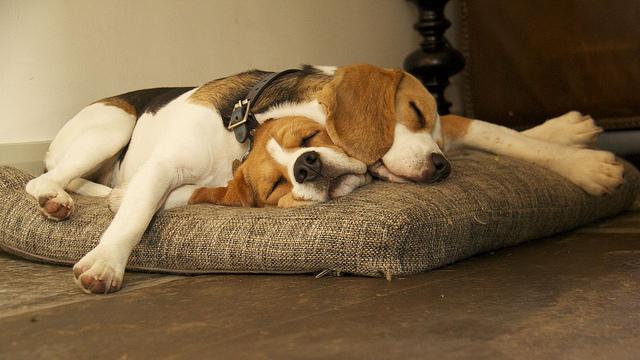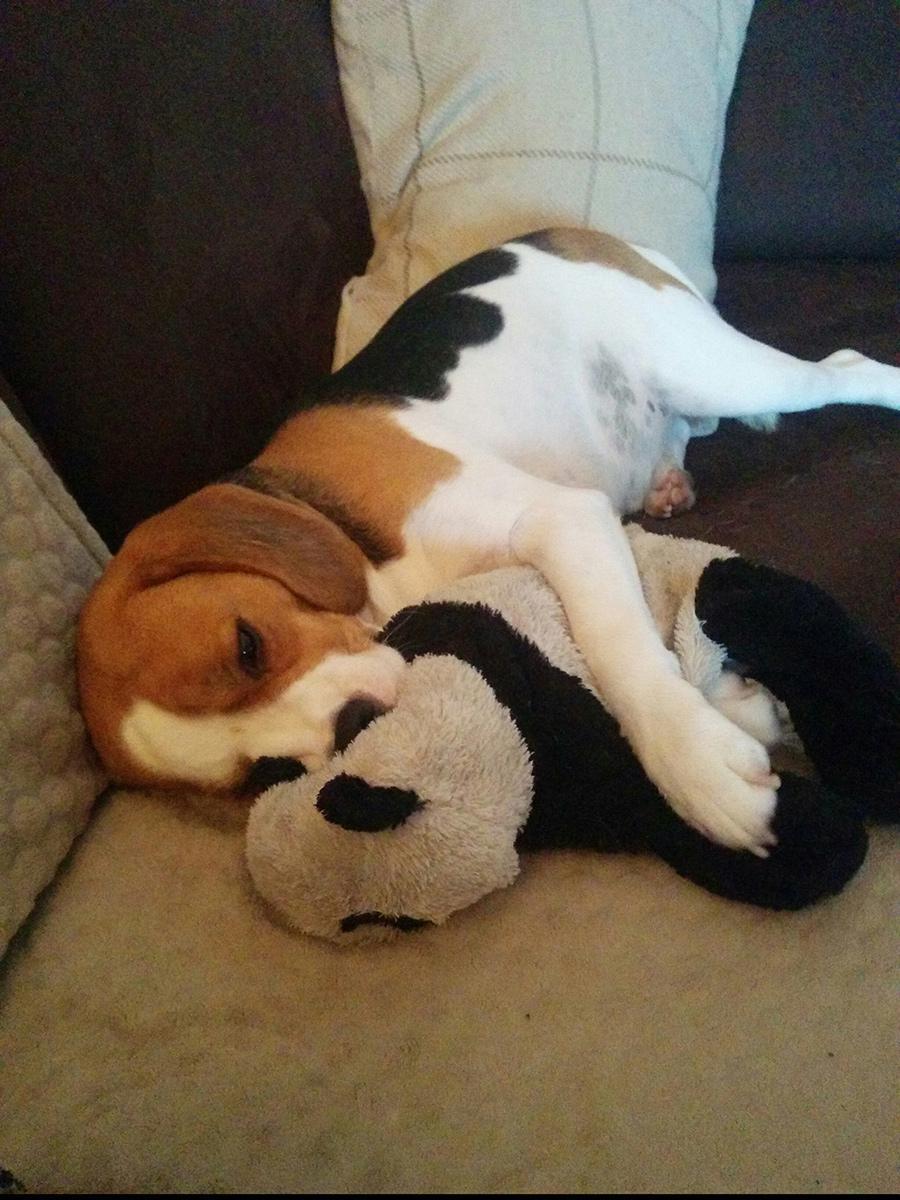The first image is the image on the left, the second image is the image on the right. Examine the images to the left and right. Is the description "One puppy is holding a stuffed animal." accurate? Answer yes or no. Yes. The first image is the image on the left, the second image is the image on the right. Assess this claim about the two images: "In one image a dog lying on its side has a front leg over a stuffed animal which it has pulled close, while in a second image, at least two dogs are sleeping.". Correct or not? Answer yes or no. Yes. 